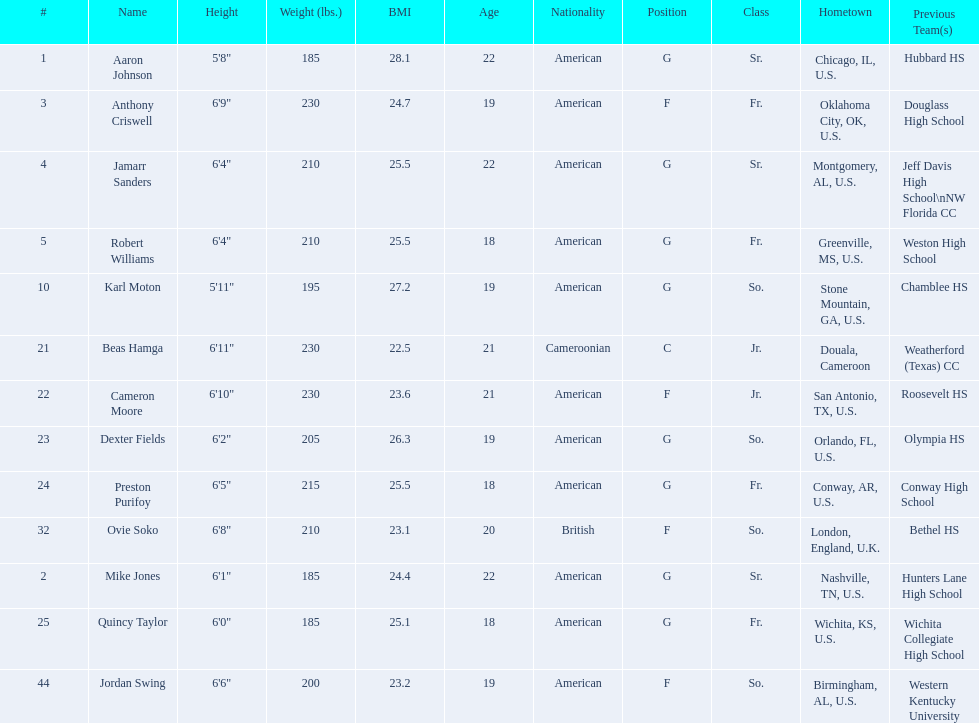Who are all the players? Aaron Johnson, Anthony Criswell, Jamarr Sanders, Robert Williams, Karl Moton, Beas Hamga, Cameron Moore, Dexter Fields, Preston Purifoy, Ovie Soko, Mike Jones, Quincy Taylor, Jordan Swing. Of these, which are not soko? Aaron Johnson, Anthony Criswell, Jamarr Sanders, Robert Williams, Karl Moton, Beas Hamga, Cameron Moore, Dexter Fields, Preston Purifoy, Mike Jones, Quincy Taylor, Jordan Swing. Where are these players from? Sr., Fr., Sr., Fr., So., Jr., Jr., So., Fr., Sr., Fr., So. Of these locations, which are not in the u.s.? Jr. Which player is from this location? Beas Hamga. 